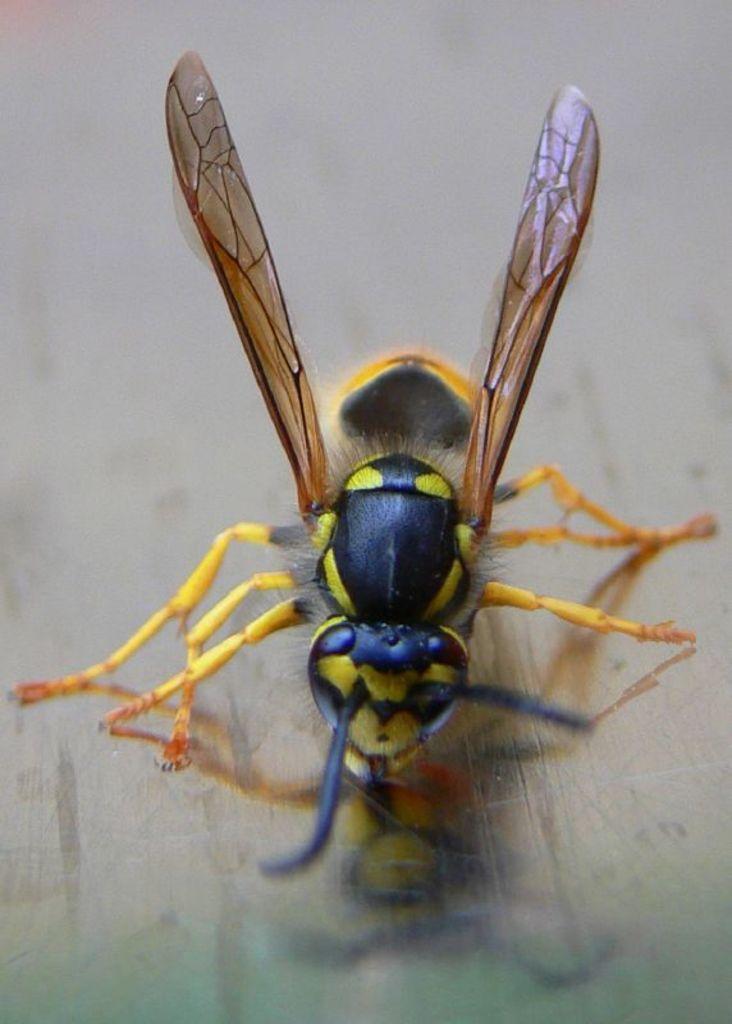Can you describe this image briefly? In this image we can see an insect on the wooden surface. 